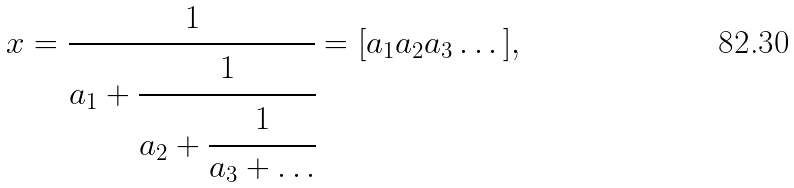<formula> <loc_0><loc_0><loc_500><loc_500>x = \cfrac { 1 } { a _ { 1 } + \cfrac { 1 } { a _ { 2 } + \cfrac { 1 } { a _ { 3 } + \dots } } } = [ a _ { 1 } a _ { 2 } a _ { 3 } \dots ] ,</formula> 